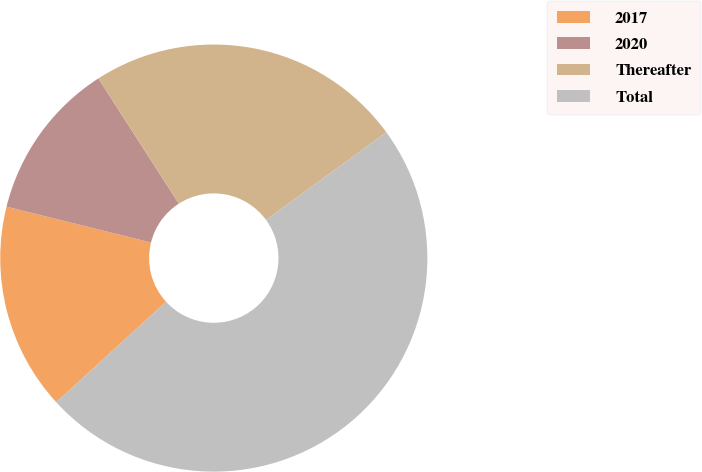Convert chart to OTSL. <chart><loc_0><loc_0><loc_500><loc_500><pie_chart><fcel>2017<fcel>2020<fcel>Thereafter<fcel>Total<nl><fcel>15.66%<fcel>12.04%<fcel>24.06%<fcel>48.23%<nl></chart> 